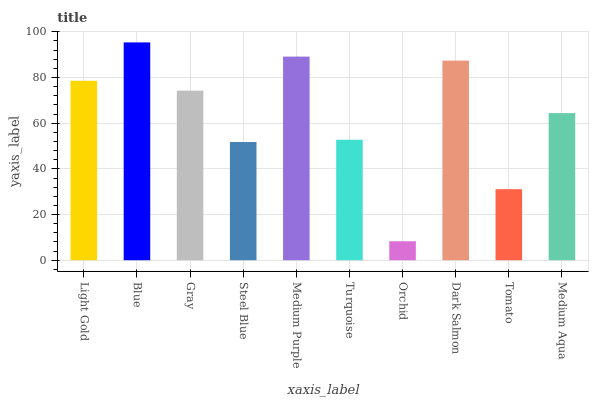Is Orchid the minimum?
Answer yes or no. Yes. Is Blue the maximum?
Answer yes or no. Yes. Is Gray the minimum?
Answer yes or no. No. Is Gray the maximum?
Answer yes or no. No. Is Blue greater than Gray?
Answer yes or no. Yes. Is Gray less than Blue?
Answer yes or no. Yes. Is Gray greater than Blue?
Answer yes or no. No. Is Blue less than Gray?
Answer yes or no. No. Is Gray the high median?
Answer yes or no. Yes. Is Medium Aqua the low median?
Answer yes or no. Yes. Is Dark Salmon the high median?
Answer yes or no. No. Is Light Gold the low median?
Answer yes or no. No. 